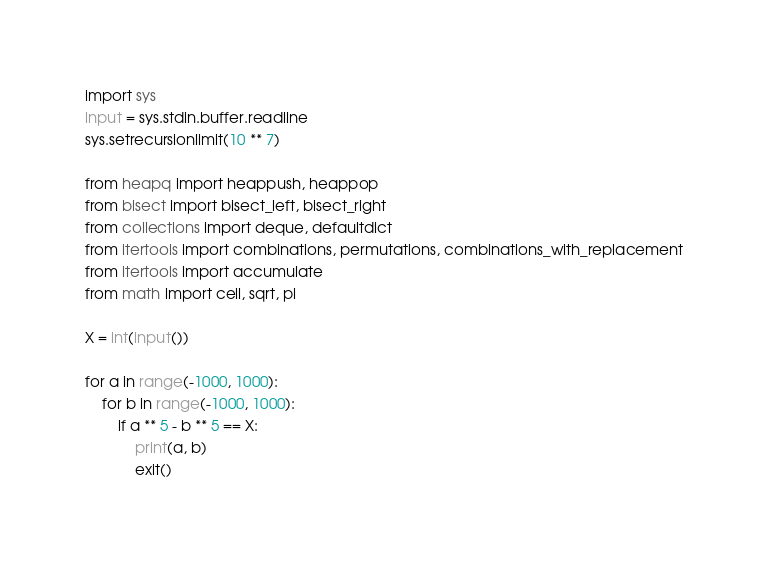Convert code to text. <code><loc_0><loc_0><loc_500><loc_500><_Python_>import sys
input = sys.stdin.buffer.readline
sys.setrecursionlimit(10 ** 7)

from heapq import heappush, heappop
from bisect import bisect_left, bisect_right
from collections import deque, defaultdict
from itertools import combinations, permutations, combinations_with_replacement
from itertools import accumulate
from math import ceil, sqrt, pi

X = int(input())

for a in range(-1000, 1000):
    for b in range(-1000, 1000):
        if a ** 5 - b ** 5 == X:
            print(a, b)
            exit()</code> 